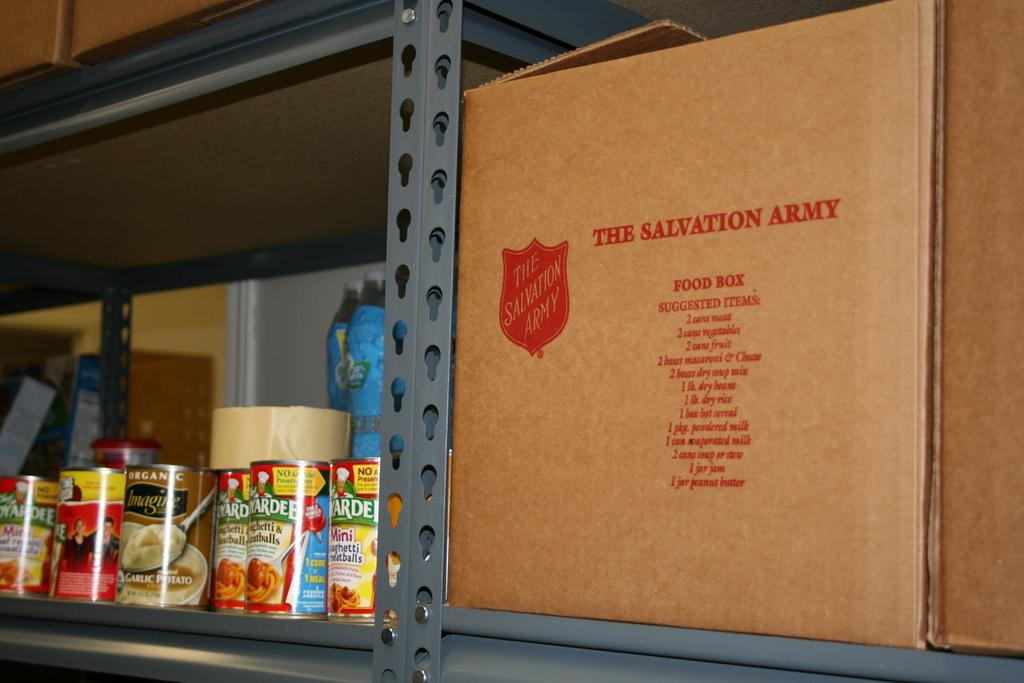<image>
Relay a brief, clear account of the picture shown. A box with a Salvation Army label Since next to some canned goods. 